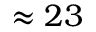Convert formula to latex. <formula><loc_0><loc_0><loc_500><loc_500>\approx 2 3</formula> 